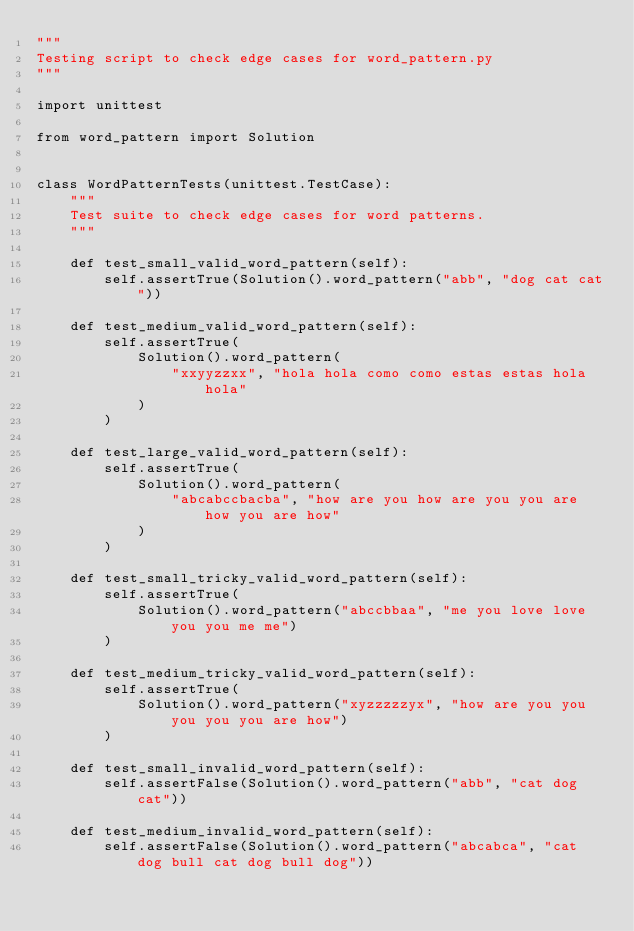<code> <loc_0><loc_0><loc_500><loc_500><_Python_>"""
Testing script to check edge cases for word_pattern.py
"""

import unittest

from word_pattern import Solution


class WordPatternTests(unittest.TestCase):
    """
    Test suite to check edge cases for word patterns.
    """

    def test_small_valid_word_pattern(self):
        self.assertTrue(Solution().word_pattern("abb", "dog cat cat"))

    def test_medium_valid_word_pattern(self):
        self.assertTrue(
            Solution().word_pattern(
                "xxyyzzxx", "hola hola como como estas estas hola hola"
            )
        )

    def test_large_valid_word_pattern(self):
        self.assertTrue(
            Solution().word_pattern(
                "abcabccbacba", "how are you how are you you are how you are how"
            )
        )

    def test_small_tricky_valid_word_pattern(self):
        self.assertTrue(
            Solution().word_pattern("abccbbaa", "me you love love you you me me")
        )

    def test_medium_tricky_valid_word_pattern(self):
        self.assertTrue(
            Solution().word_pattern("xyzzzzzyx", "how are you you you you you are how")
        )

    def test_small_invalid_word_pattern(self):
        self.assertFalse(Solution().word_pattern("abb", "cat dog cat"))

    def test_medium_invalid_word_pattern(self):
        self.assertFalse(Solution().word_pattern("abcabca", "cat dog bull cat dog bull dog"))
</code> 